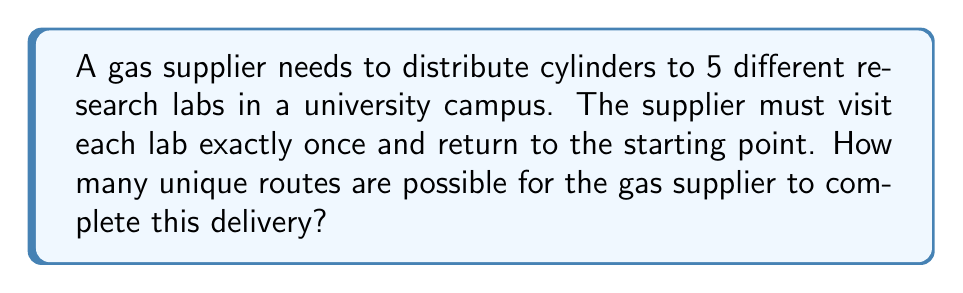Give your solution to this math problem. Let's approach this step-by-step:

1) This problem is equivalent to finding the number of possible circular permutations of 5 distinct elements.

2) For a linear permutation of n distinct elements, we have n! possibilities.

3) However, in a circular permutation, rotations of the same arrangement are considered identical. For example, the routes 1-2-3-4-5, 2-3-4-5-1, 3-4-5-1-2, 4-5-1-2-3, and 5-1-2-3-4 are all considered the same circular permutation.

4) The number of such rotations for n elements is always n.

5) Therefore, to get the number of unique circular permutations, we need to divide the total number of linear permutations by n.

6) The formula for the number of unique circular permutations of n distinct elements is:

   $$(n-1)!$$

7) In this case, n = 5 (5 research labs).

8) So, the number of unique routes is:

   $$(5-1)! = 4! = 4 \times 3 \times 2 \times 1 = 24$$

Therefore, there are 24 unique routes for the gas supplier to complete the delivery.
Answer: 24 